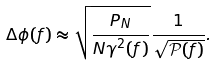Convert formula to latex. <formula><loc_0><loc_0><loc_500><loc_500>\Delta \phi ( f ) \approx \sqrt { \frac { P _ { N } } { N \gamma ^ { 2 } ( f ) } } \frac { 1 } { \sqrt { \mathcal { P } ( f ) } } .</formula> 